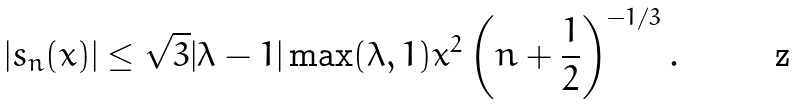Convert formula to latex. <formula><loc_0><loc_0><loc_500><loc_500>\left | s _ { n } ( x ) \right | \leq \sqrt { 3 } | \lambda - 1 | \max ( \lambda , 1 ) x ^ { 2 } \left ( n + \frac { 1 } { 2 } \right ) ^ { - 1 / 3 } .</formula> 